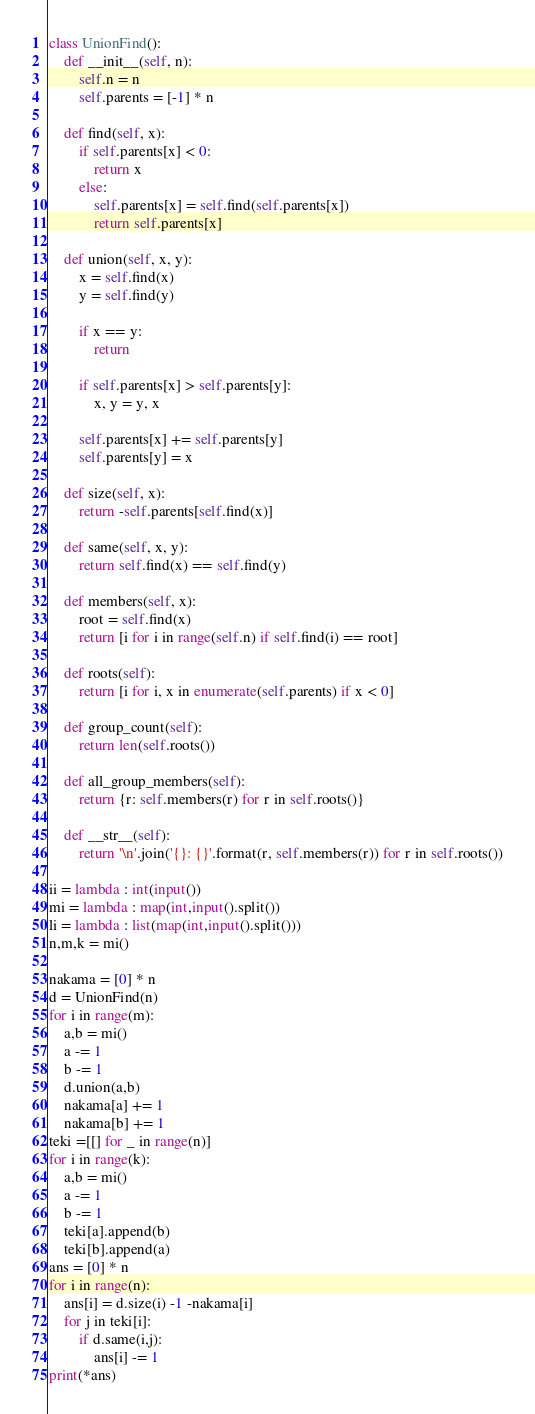Convert code to text. <code><loc_0><loc_0><loc_500><loc_500><_Python_>class UnionFind():
    def __init__(self, n):
        self.n = n
        self.parents = [-1] * n

    def find(self, x):
        if self.parents[x] < 0:
            return x
        else:
            self.parents[x] = self.find(self.parents[x])
            return self.parents[x]

    def union(self, x, y):
        x = self.find(x)
        y = self.find(y)

        if x == y:
            return

        if self.parents[x] > self.parents[y]:
            x, y = y, x

        self.parents[x] += self.parents[y]
        self.parents[y] = x

    def size(self, x):
        return -self.parents[self.find(x)]

    def same(self, x, y):
        return self.find(x) == self.find(y)

    def members(self, x):
        root = self.find(x)
        return [i for i in range(self.n) if self.find(i) == root]

    def roots(self):
        return [i for i, x in enumerate(self.parents) if x < 0]

    def group_count(self):
        return len(self.roots())

    def all_group_members(self):
        return {r: self.members(r) for r in self.roots()}

    def __str__(self):
        return '\n'.join('{}: {}'.format(r, self.members(r)) for r in self.roots())

ii = lambda : int(input())
mi = lambda : map(int,input().split())
li = lambda : list(map(int,input().split()))
n,m,k = mi()

nakama = [0] * n
d = UnionFind(n)
for i in range(m):
    a,b = mi()
    a -= 1
    b -= 1
    d.union(a,b)
    nakama[a] += 1
    nakama[b] += 1
teki =[[] for _ in range(n)]
for i in range(k):
    a,b = mi()
    a -= 1
    b -= 1
    teki[a].append(b)
    teki[b].append(a)
ans = [0] * n
for i in range(n):
    ans[i] = d.size(i) -1 -nakama[i]
    for j in teki[i]:
        if d.same(i,j):
            ans[i] -= 1
print(*ans)

</code> 